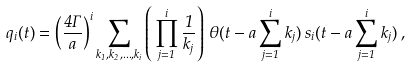Convert formula to latex. <formula><loc_0><loc_0><loc_500><loc_500>q _ { i } ( t ) = \left ( \frac { 4 \Gamma } { a } \right ) ^ { i } \sum _ { k _ { 1 } , k _ { 2 } , \dots , k _ { i } } \left ( \, \prod _ { j = 1 } ^ { i } \frac { 1 } { k _ { j } } \right ) \, \theta ( t - a \sum _ { j = 1 } ^ { i } k _ { j } ) \, s _ { i } ( t - a \sum _ { j = 1 } ^ { i } k _ { j } ) \, ,</formula> 